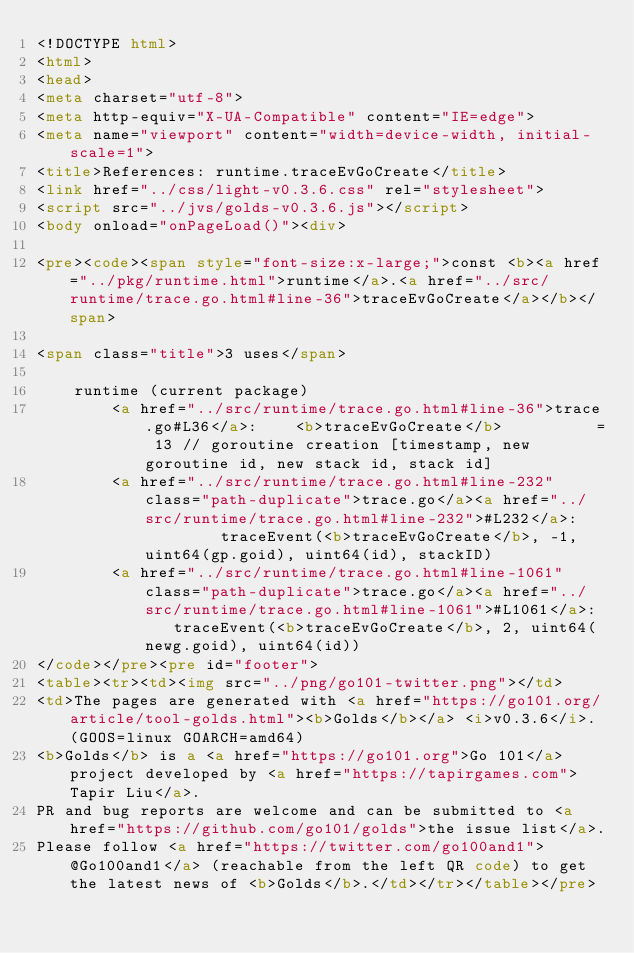<code> <loc_0><loc_0><loc_500><loc_500><_HTML_><!DOCTYPE html>
<html>
<head>
<meta charset="utf-8">
<meta http-equiv="X-UA-Compatible" content="IE=edge">
<meta name="viewport" content="width=device-width, initial-scale=1">
<title>References: runtime.traceEvGoCreate</title>
<link href="../css/light-v0.3.6.css" rel="stylesheet">
<script src="../jvs/golds-v0.3.6.js"></script>
<body onload="onPageLoad()"><div>

<pre><code><span style="font-size:x-large;">const <b><a href="../pkg/runtime.html">runtime</a>.<a href="../src/runtime/trace.go.html#line-36">traceEvGoCreate</a></b></span>

<span class="title">3 uses</span>

	runtime (current package)
		<a href="../src/runtime/trace.go.html#line-36">trace.go#L36</a>: 	<b>traceEvGoCreate</b>          = 13 // goroutine creation [timestamp, new goroutine id, new stack id, stack id]
		<a href="../src/runtime/trace.go.html#line-232" class="path-duplicate">trace.go</a><a href="../src/runtime/trace.go.html#line-232">#L232</a>: 			traceEvent(<b>traceEvGoCreate</b>, -1, uint64(gp.goid), uint64(id), stackID)
		<a href="../src/runtime/trace.go.html#line-1061" class="path-duplicate">trace.go</a><a href="../src/runtime/trace.go.html#line-1061">#L1061</a>: 	traceEvent(<b>traceEvGoCreate</b>, 2, uint64(newg.goid), uint64(id))
</code></pre><pre id="footer">
<table><tr><td><img src="../png/go101-twitter.png"></td>
<td>The pages are generated with <a href="https://go101.org/article/tool-golds.html"><b>Golds</b></a> <i>v0.3.6</i>. (GOOS=linux GOARCH=amd64)
<b>Golds</b> is a <a href="https://go101.org">Go 101</a> project developed by <a href="https://tapirgames.com">Tapir Liu</a>.
PR and bug reports are welcome and can be submitted to <a href="https://github.com/go101/golds">the issue list</a>.
Please follow <a href="https://twitter.com/go100and1">@Go100and1</a> (reachable from the left QR code) to get the latest news of <b>Golds</b>.</td></tr></table></pre></code> 